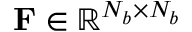Convert formula to latex. <formula><loc_0><loc_0><loc_500><loc_500>F \in \mathbb { R } ^ { N _ { b } \times N _ { b } }</formula> 